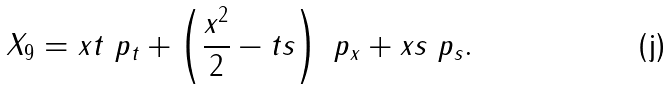Convert formula to latex. <formula><loc_0><loc_0><loc_500><loc_500>X _ { 9 } = x t \ p _ { t } + \left ( \frac { x ^ { 2 } } { 2 } - t s \right ) \ p _ { x } + x s \ p _ { s } .</formula> 